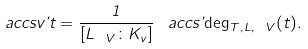<formula> <loc_0><loc_0><loc_500><loc_500>\ a c c s v { \varphi } { t } = \frac { 1 } { [ L _ { \ V } \colon K _ { v } ] } \, \ a c c s { \varphi } { \deg _ { T , L , \ V } ( t ) } .</formula> 